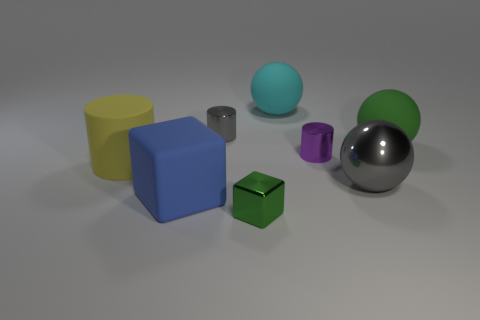How many other objects are the same size as the blue cube?
Keep it short and to the point. 4. Are there any big blue cubes behind the small metal thing in front of the gray metal object that is in front of the yellow rubber cylinder?
Make the answer very short. Yes. What is the size of the green matte object?
Provide a short and direct response. Large. There is a gray metal sphere in front of the cyan matte object; how big is it?
Offer a very short reply. Large. There is a matte sphere that is to the left of the purple thing; is it the same size as the matte block?
Keep it short and to the point. Yes. Is there anything else of the same color as the large cube?
Make the answer very short. No. The big blue object has what shape?
Offer a very short reply. Cube. How many objects are in front of the large yellow rubber object and to the right of the cyan matte object?
Offer a very short reply. 1. There is a gray object that is the same shape as the cyan matte object; what material is it?
Make the answer very short. Metal. Are there the same number of purple objects that are left of the large yellow matte thing and green objects in front of the large blue rubber object?
Offer a very short reply. No. 